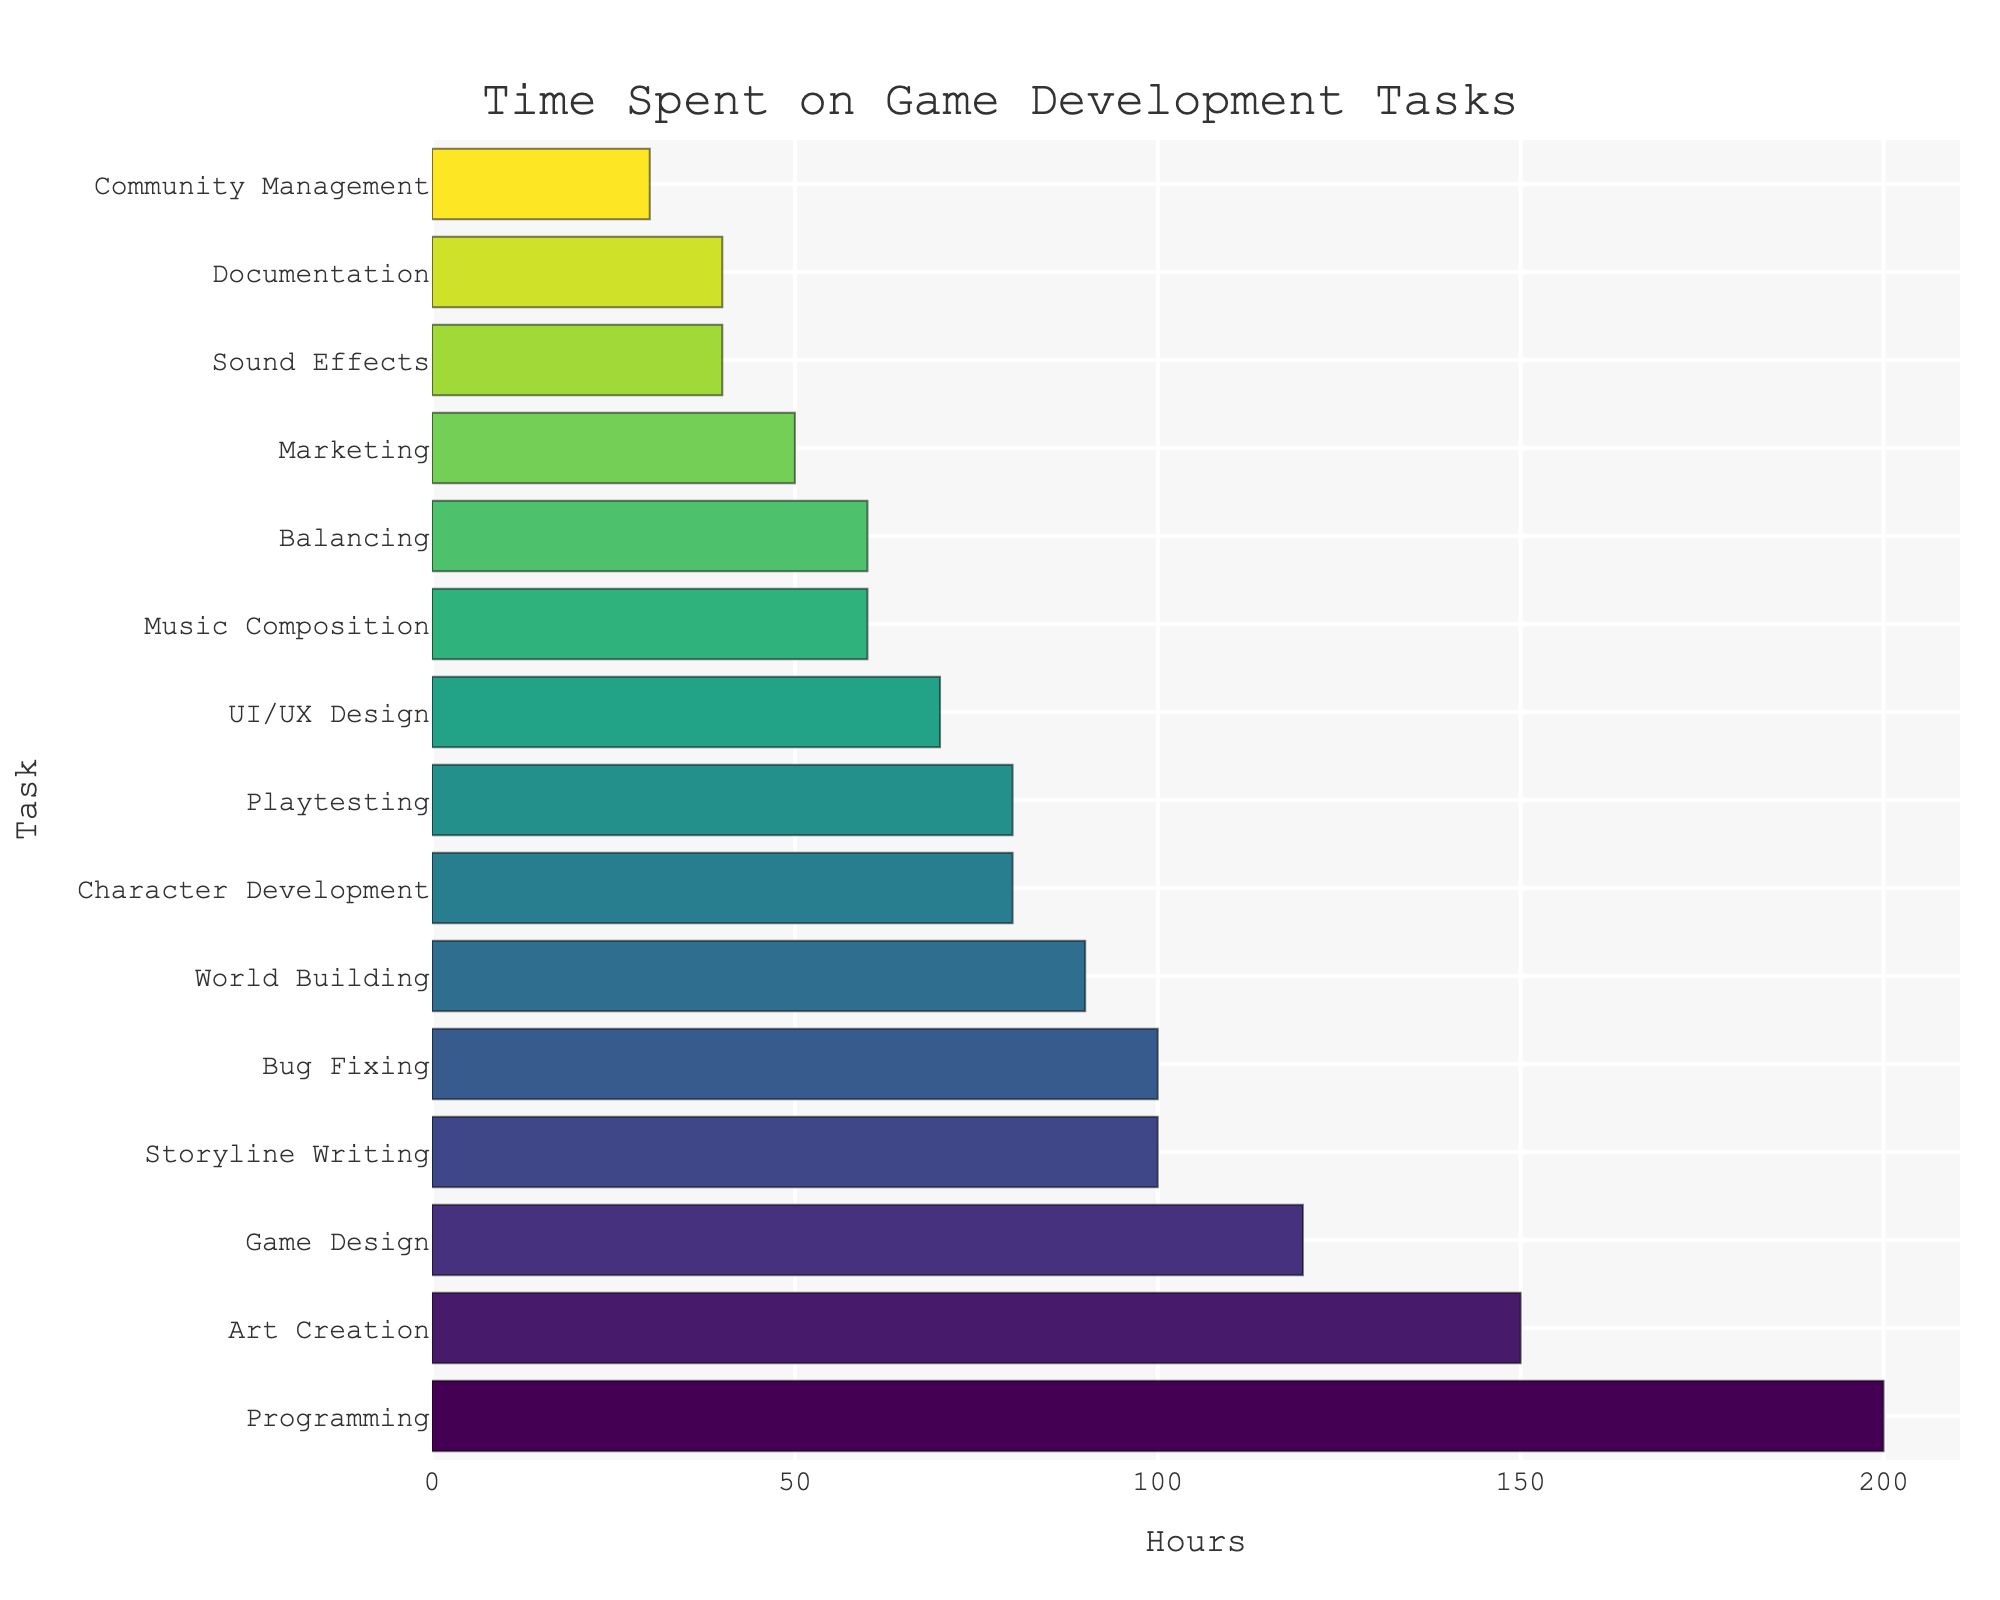Which task requires the most time? The bar chart shows various tasks on the y-axis and the hours spent on each task on the x-axis. The longest bar represents the task that requires the most time. It is the task labeled "Programming" with 200 hours.
Answer: Programming How many more hours are spent on Art Creation compared to Documentation? The bar for Art Creation indicates 150 hours, while the bar for Documentation indicates 40 hours. To find the difference, subtract 40 from 150.
Answer: 110 What is the sum of the hours spent on Playtesting and Balancing? Playtesting shows 80 hours and Balancing shows 60 hours. Adding these together gives 80 + 60 = 140.
Answer: 140 Which task has the shortest bar? The bar chart presents several tasks with varying bar lengths. The shortest bar represents the task with the least hours. It is "Community Management" with 30 hours.
Answer: Community Management Compare the total time spent on Storyline Writing, Character Development, and World Building. How many hours are spent in total? Storyline Writing is 100 hours, Character Development is 80 hours, and World Building is 90 hours. Adding these together gives 100 + 80 + 90 = 270 hours.
Answer: 270 Is more time spent on UI/UX Design or Bug Fixing, and by how much? UI/UX Design is 70 hours, and Bug Fixing is 100 hours. Subtracting 70 from 100 gives 100 - 70 = 30 hours more spent on Bug Fixing.
Answer: Bug Fixing by 30 Which color represents the task with the most hours spent? The task with the most hours is Programming, displayed by the longest bar. The color scale ranges from light to dark, with Programming being in a darker shade as it has the highest value within the color range used.
Answer: Darker shade What is the average time spent on Game Design, Music Composition, and Sound Effects? Game Design is 120 hours, Music Composition is 60 hours, and Sound Effects are 40 hours. Adding these together gives 120 + 60 + 40 = 220. Dividing by 3, 220 / 3 ≈ 73.33 hours.
Answer: ~73.33 Are more hours spent on Marketing or Community Management? Marketing shows 50 hours, while Community Management is 30 hours. Looking at the lengths of these bars confirms that Marketing has more hours.
Answer: Marketing What is the visual pattern observed for the tasks that are related to audio content (Music Composition and Sound Effects)? Both Music Composition (60 hours) and Sound Effects (40 hours) have relatively short bars, lighter in color since the hours are lower in comparison with other tasks.
Answer: Relatively short bars and lighter color 